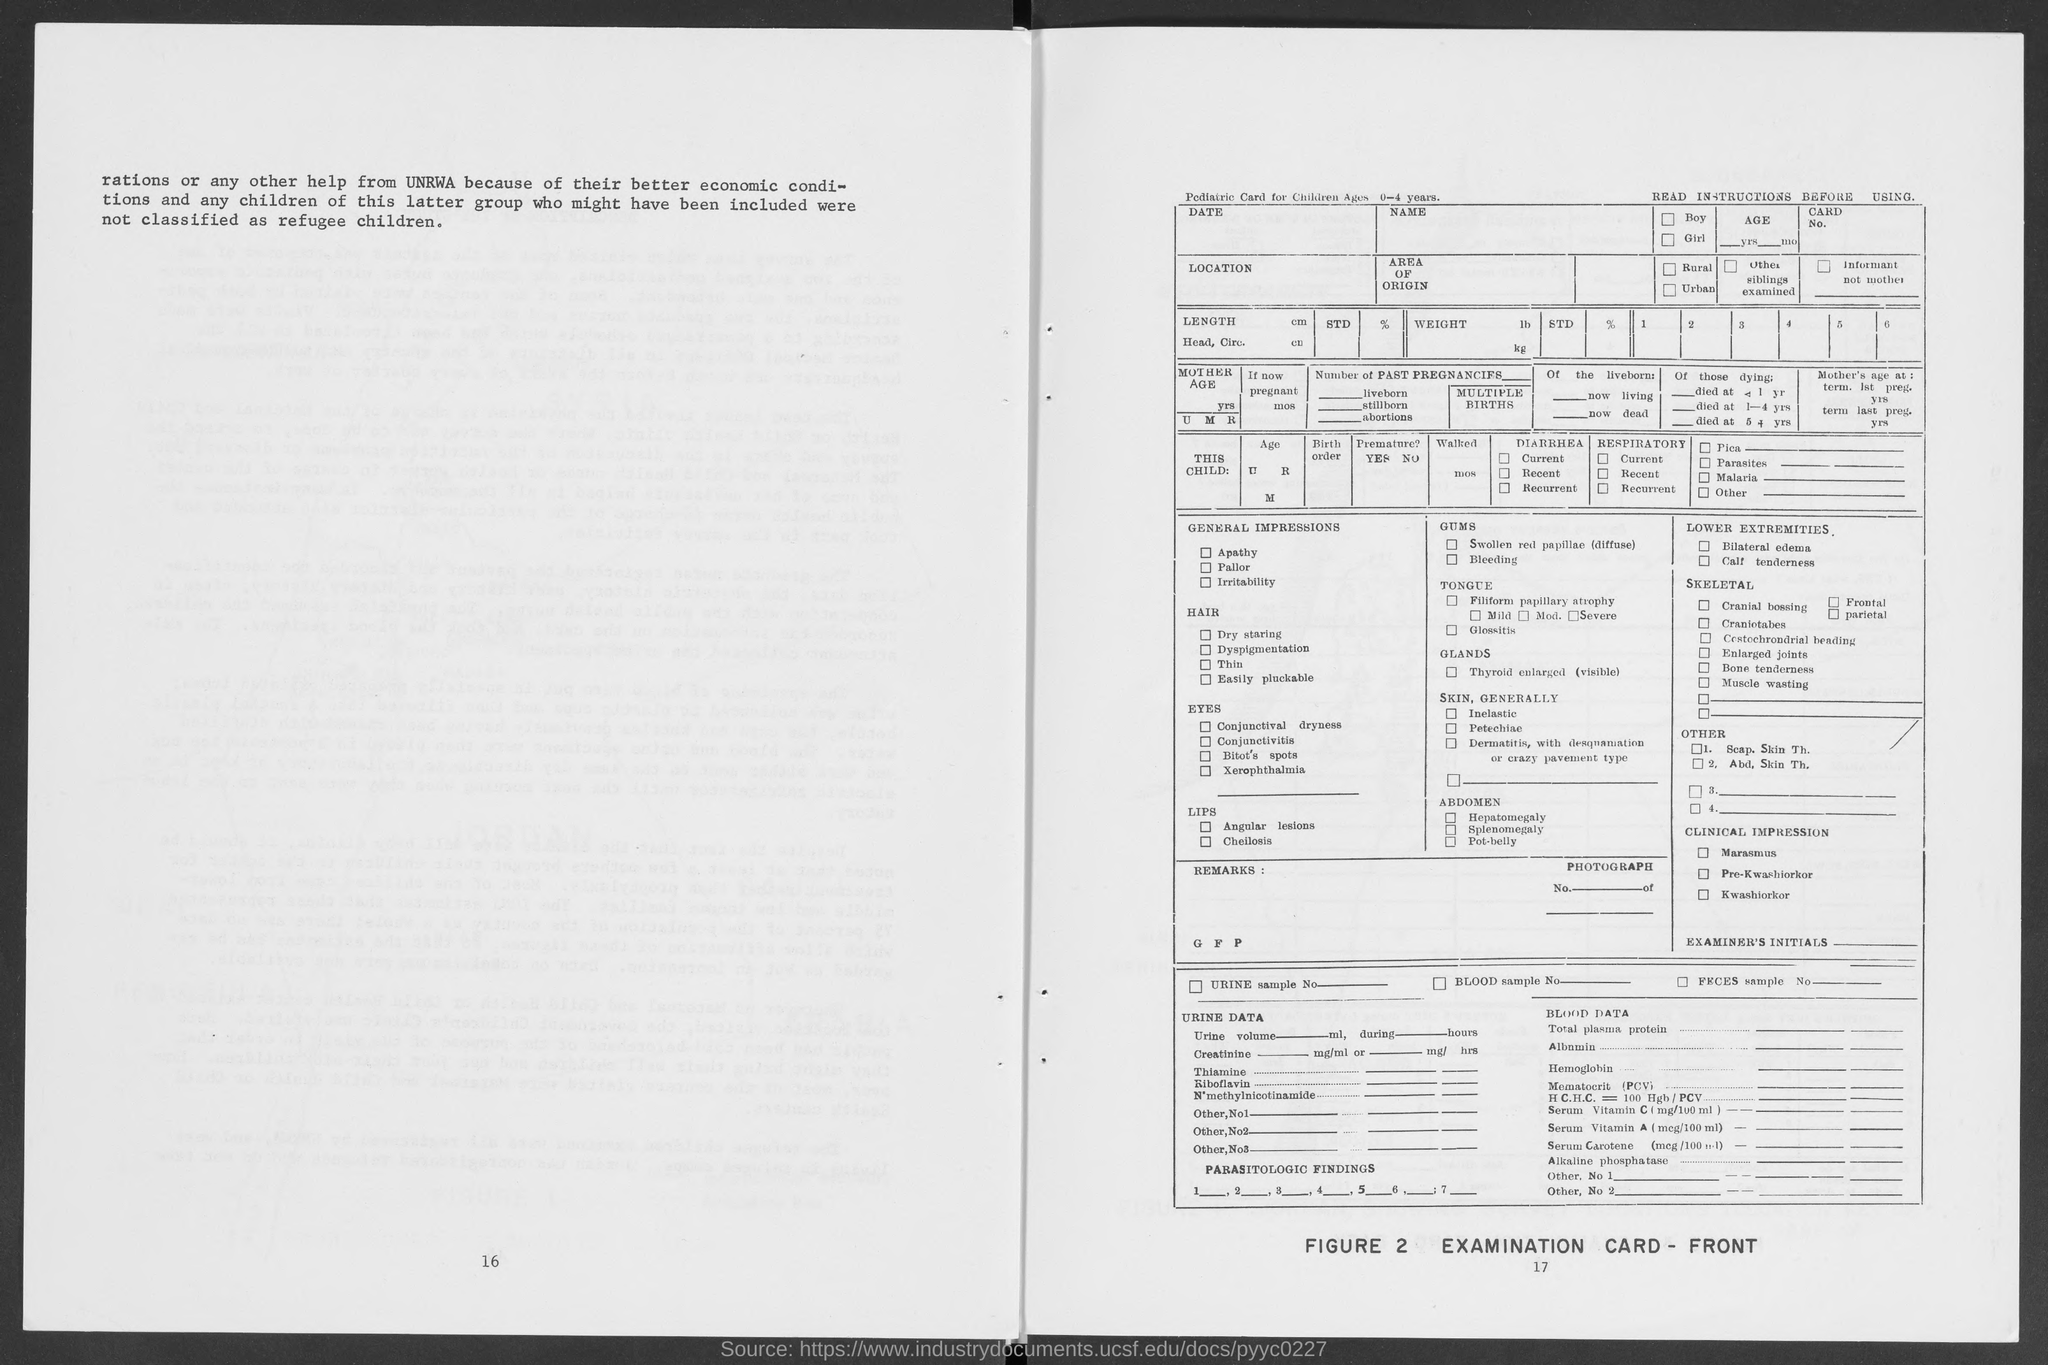What is the Title of Figure 2?
Provide a succinct answer. Examination Card - Front. 